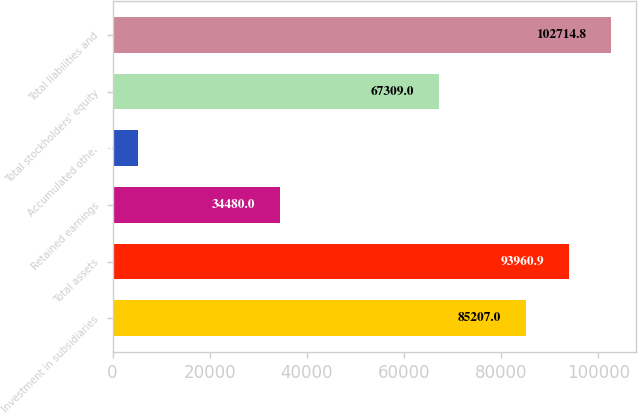<chart> <loc_0><loc_0><loc_500><loc_500><bar_chart><fcel>Investment in subsidiaries<fcel>Total assets<fcel>Retained earnings<fcel>Accumulated other<fcel>Total stockholders' equity<fcel>Total liabilities and<nl><fcel>85207<fcel>93960.9<fcel>34480<fcel>5347<fcel>67309<fcel>102715<nl></chart> 